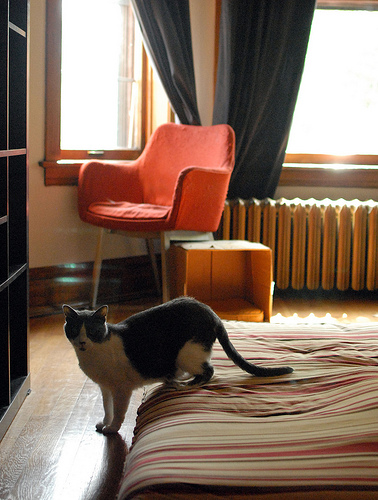<image>
Is there a cat next to the window? No. The cat is not positioned next to the window. They are located in different areas of the scene. 